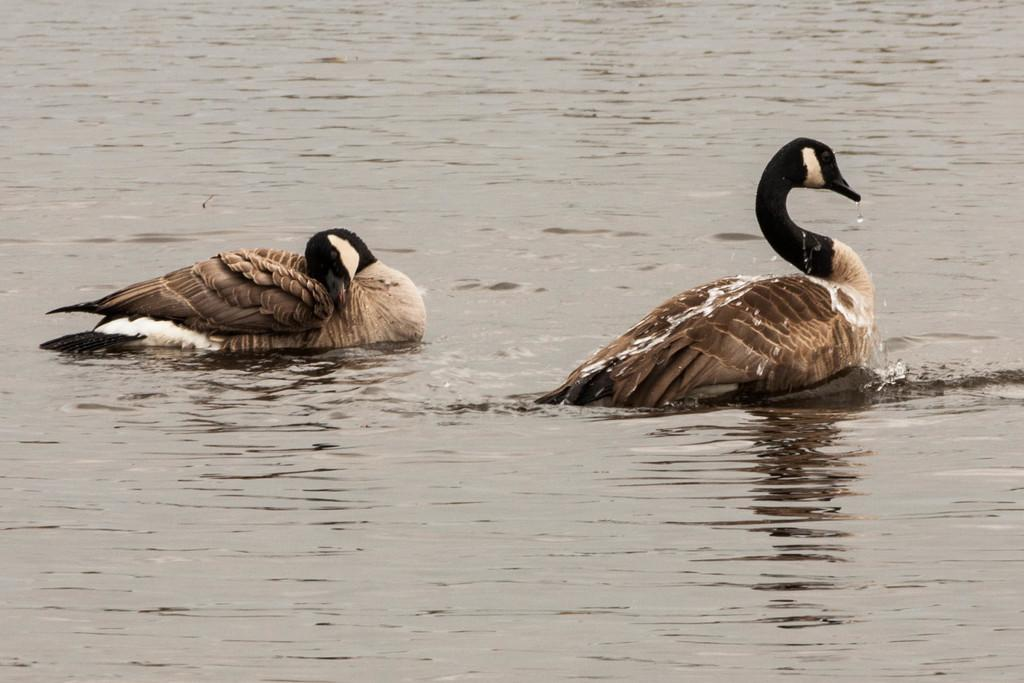How many ducks are present in the image? There are two ducks in the image. What are the ducks doing in the image? The ducks are swimming in a lake. What type of beds can be seen in the image? There are no beds present in the image; it features two ducks swimming in a lake. What is the title of the image? The image does not have a title, as it is a photograph or illustration and not a piece of literature or artwork with a specific title. 